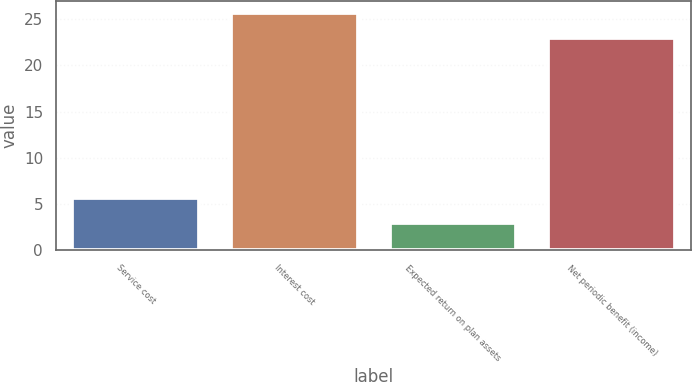Convert chart to OTSL. <chart><loc_0><loc_0><loc_500><loc_500><bar_chart><fcel>Service cost<fcel>Interest cost<fcel>Expected return on plan assets<fcel>Net periodic benefit (income)<nl><fcel>5.7<fcel>25.7<fcel>3<fcel>23<nl></chart> 